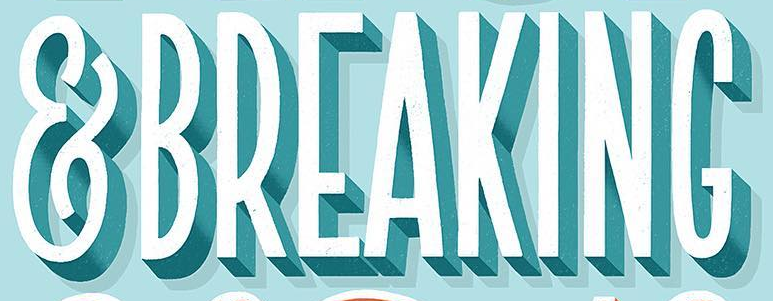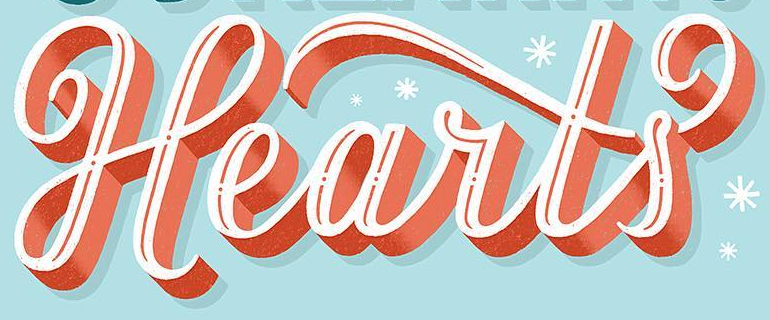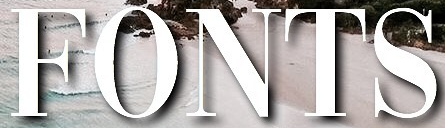What words are shown in these images in order, separated by a semicolon? &BREAKING; Hearts; FONTS 